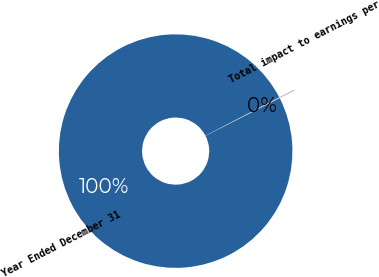Convert chart to OTSL. <chart><loc_0><loc_0><loc_500><loc_500><pie_chart><fcel>Year Ended December 31<fcel>Total impact to earnings per<nl><fcel>99.88%<fcel>0.12%<nl></chart> 